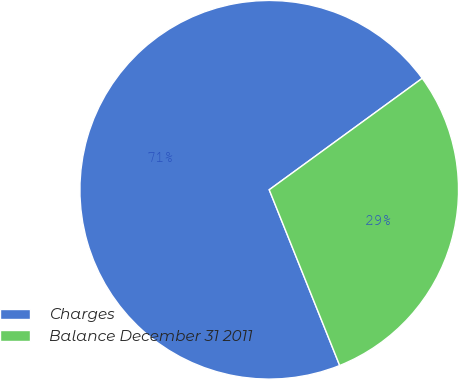Convert chart to OTSL. <chart><loc_0><loc_0><loc_500><loc_500><pie_chart><fcel>Charges<fcel>Balance December 31 2011<nl><fcel>71.05%<fcel>28.95%<nl></chart> 